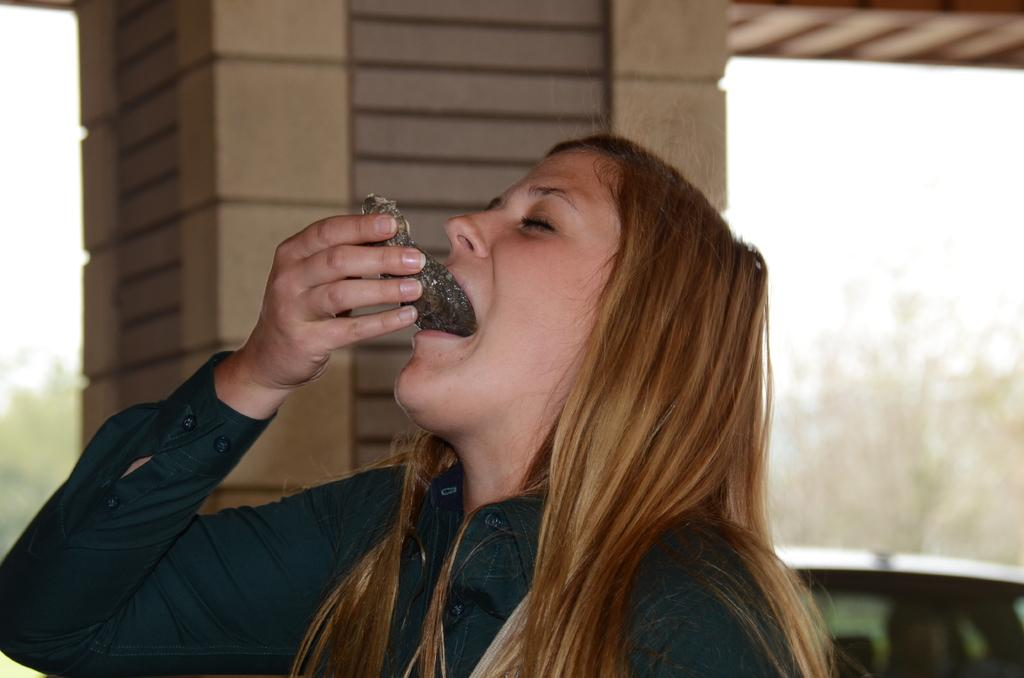What is the main subject of the image? There is a person standing in the image. What is the person doing in the image? The person is eating a food item. What other object can be seen in the image? There is a pillar in the image. How would you describe the background of the image? The background of the image is blurred. What type of cork can be seen in the image? There is no cork present in the image. How does the bear interact with the person in the image? There is no bear present in the image. 